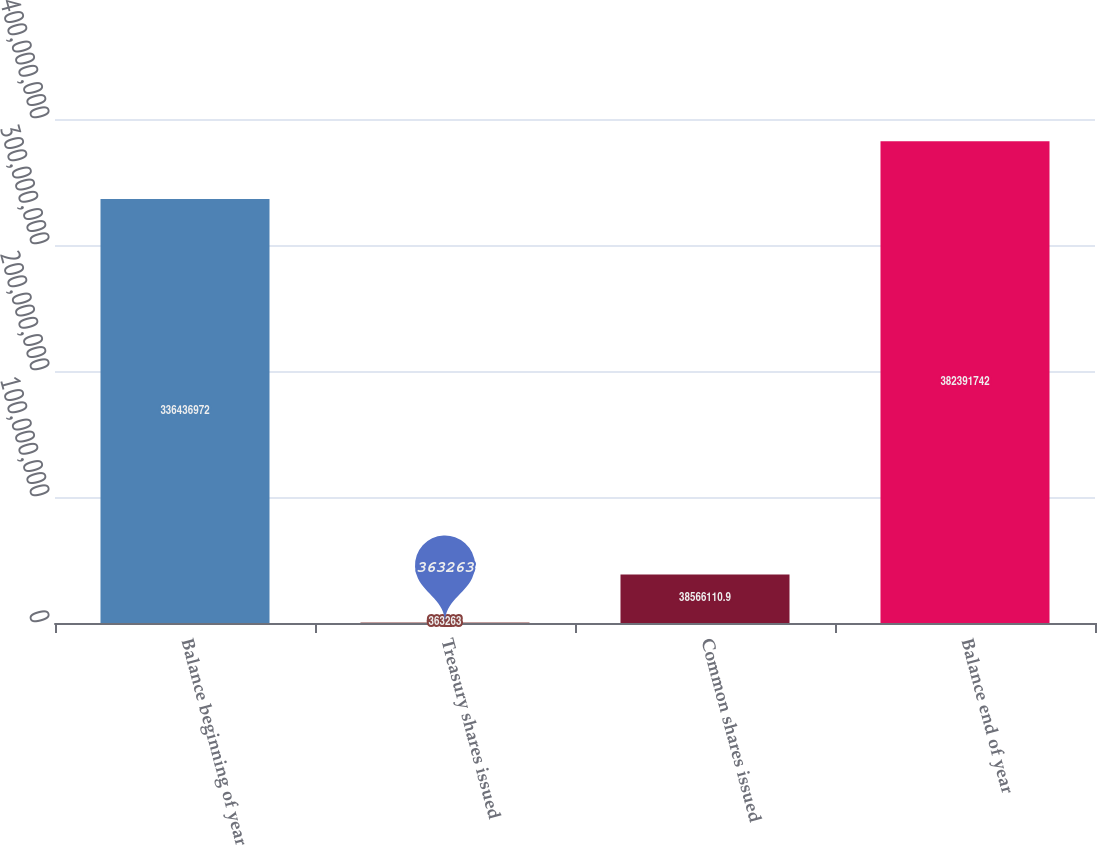Convert chart. <chart><loc_0><loc_0><loc_500><loc_500><bar_chart><fcel>Balance beginning of year<fcel>Treasury shares issued<fcel>Common shares issued<fcel>Balance end of year<nl><fcel>3.36437e+08<fcel>363263<fcel>3.85661e+07<fcel>3.82392e+08<nl></chart> 